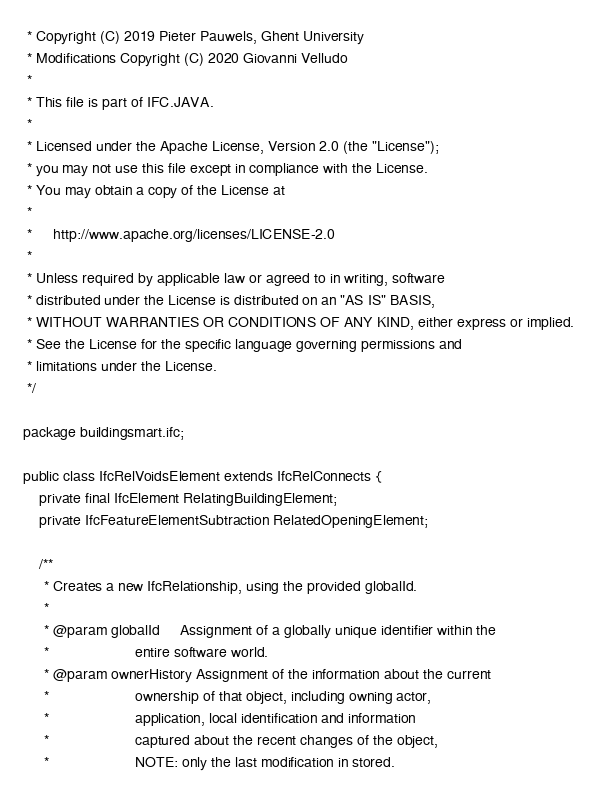Convert code to text. <code><loc_0><loc_0><loc_500><loc_500><_Java_> * Copyright (C) 2019 Pieter Pauwels, Ghent University
 * Modifications Copyright (C) 2020 Giovanni Velludo
 *
 * This file is part of IFC.JAVA.
 *
 * Licensed under the Apache License, Version 2.0 (the "License");
 * you may not use this file except in compliance with the License.
 * You may obtain a copy of the License at
 *
 *     http://www.apache.org/licenses/LICENSE-2.0
 *
 * Unless required by applicable law or agreed to in writing, software
 * distributed under the License is distributed on an "AS IS" BASIS,
 * WITHOUT WARRANTIES OR CONDITIONS OF ANY KIND, either express or implied.
 * See the License for the specific language governing permissions and
 * limitations under the License.
 */

package buildingsmart.ifc;

public class IfcRelVoidsElement extends IfcRelConnects {
    private final IfcElement RelatingBuildingElement;
    private IfcFeatureElementSubtraction RelatedOpeningElement;

    /**
     * Creates a new IfcRelationship, using the provided globalId.
     *
     * @param globalId     Assignment of a globally unique identifier within the
     *                     entire software world.
     * @param ownerHistory Assignment of the information about the current
     *                     ownership of that object, including owning actor,
     *                     application, local identification and information
     *                     captured about the recent changes of the object,
     *                     NOTE: only the last modification in stored.</code> 